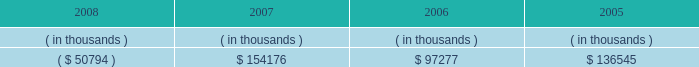Entergy texas , inc .
Management's financial discussion and analysis dividends or other distributions on its common stock .
Currently , all of entergy texas' retained earnings are available for distribution .
Sources of capital entergy texas' sources to meet its capital requirements include : internally generated funds ; cash on hand ; debt or preferred stock issuances ; and bank financing under new or existing facilities .
Entergy texas may refinance or redeem debt prior to maturity , to the extent market conditions and interest and dividend rates are favorable .
All debt and common and preferred stock issuances by entergy texas require prior regulatory approval .
Preferred stock and debt issuances are also subject to issuance tests set forth in its corporate charter , bond indentures , and other agreements .
Entergy texas has sufficient capacity under these tests to meet its foreseeable capital needs .
Entergy gulf states , inc .
Filed with the ferc an application , on behalf of entergy texas , for authority to issue up to $ 200 million of short-term debt , up to $ 300 million of tax-exempt bonds , and up to $ 1.3 billion of other long- term securities , including common and preferred or preference stock and long-term debt .
On november 8 , 2007 , the ferc issued orders granting the requested authority for a two-year period ending november 8 , 2009 .
Entergy texas' receivables from or ( payables to ) the money pool were as follows as of december 31 for each of the following years: .
See note 4 to the financial statements for a description of the money pool .
Entergy texas has a credit facility in the amount of $ 100 million scheduled to expire in august 2012 .
As of december 31 , 2008 , $ 100 million was outstanding on the credit facility .
In february 2009 , entergy texas repaid its credit facility with the proceeds from the bond issuance discussed below .
On june 2 , 2008 and december 8 , 2008 , under the terms of the debt assumption agreement between entergy texas and entergy gulf states louisiana that is discussed in note 5 to the financial statements , entergy texas paid at maturity $ 148.8 million and $ 160.3 million , respectively , of entergy gulf states louisiana first mortgage bonds , which results in a corresponding decrease in entergy texas' debt assumption liability .
In december 2008 , entergy texas borrowed $ 160 million from its parent company , entergy corporation , under a $ 300 million revolving credit facility pursuant to an inter-company credit agreement between entergy corporation and entergy texas .
This borrowing would have matured on december 3 , 2013 .
Entergy texas used these borrowings , together with other available corporate funds , to pay at maturity the portion of the $ 350 million floating rate series of first mortgage bonds due december 2008 that had been assumed by entergy texas , and that bond series is no longer outstanding .
In january 2009 , entergy texas repaid its $ 160 million note payable to entergy corporation with the proceeds from the bond issuance discussed below .
In january 2009 , entergy texas issued $ 500 million of 7.125% ( 7.125 % ) series mortgage bonds due february 2019 .
Entergy texas used a portion of the proceeds to repay its $ 160 million note payable to entergy corporation , to repay the $ 100 million outstanding on its credit facility , and to repay short-term borrowings under the entergy system money pool .
Entergy texas intends to use the remaining proceeds to repay on or prior to maturity approximately $ 70 million of obligations that had been assumed by entergy texas under the debt assumption agreement with entergy gulf states louisiana and for other general corporate purposes. .
What is the total amount of securities that can be issued by entergy texas , in millions of dollars , if the application is accepted? 
Computations: ((1.3 * 1000) + (200 + 300))
Answer: 1800.0. 